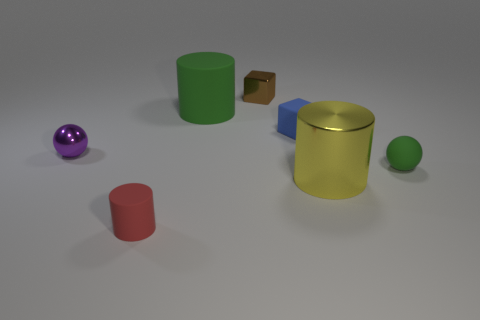What is the shape of the object that is behind the big yellow metallic thing and on the right side of the blue thing?
Your answer should be compact. Sphere. What size is the shiny thing in front of the metal object left of the green cylinder?
Keep it short and to the point. Large. How many other things are there of the same color as the shiny cylinder?
Your answer should be compact. 0. What material is the red cylinder?
Make the answer very short. Rubber. Is there a big gray cylinder?
Provide a short and direct response. No. Are there the same number of tiny brown shiny blocks that are behind the shiny sphere and big brown matte blocks?
Give a very brief answer. No. Is there any other thing that is the same material as the small brown object?
Your response must be concise. Yes. How many big things are either blue metallic cylinders or blocks?
Your response must be concise. 0. The rubber thing that is the same color as the large rubber cylinder is what shape?
Give a very brief answer. Sphere. Is the tiny thing left of the red rubber cylinder made of the same material as the big yellow cylinder?
Your answer should be very brief. Yes. 